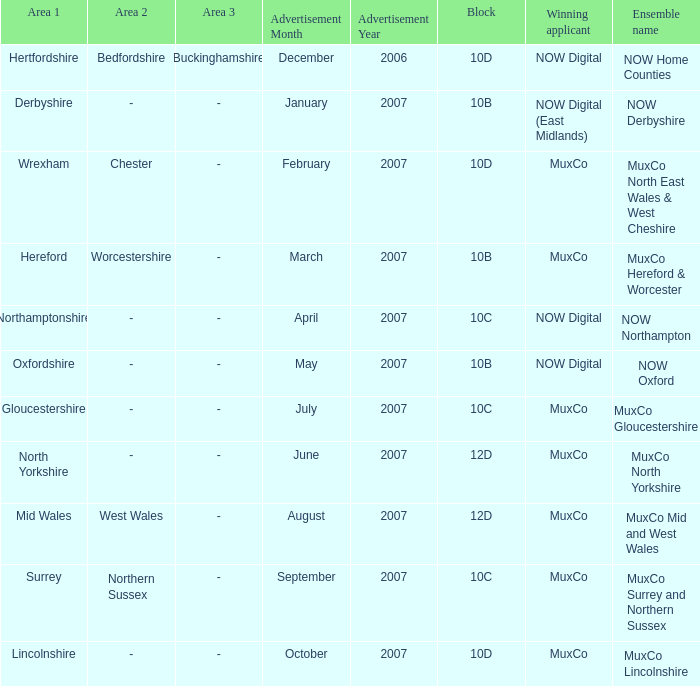Which Block does Northamptonshire Area have? 10C. 